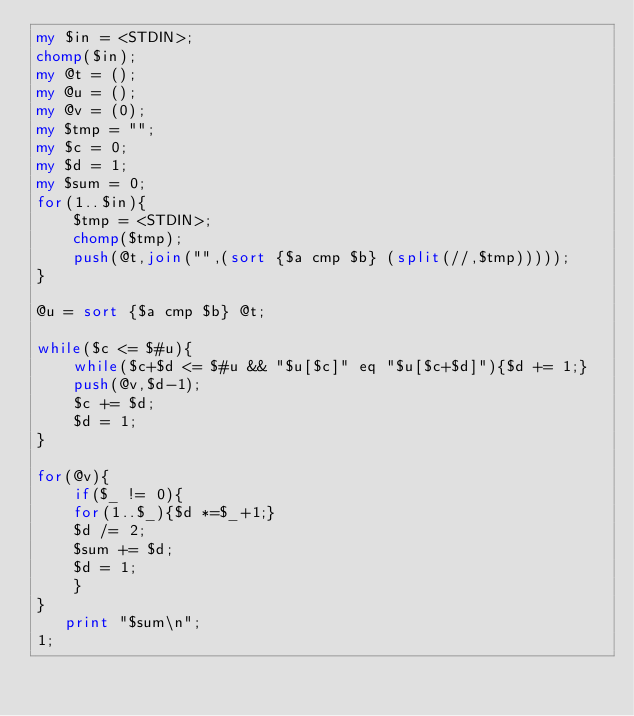Convert code to text. <code><loc_0><loc_0><loc_500><loc_500><_Perl_>my $in = <STDIN>;
chomp($in);
my @t = ();
my @u = ();
my @v = (0);
my $tmp = "";
my $c = 0;
my $d = 1;
my $sum = 0;
for(1..$in){
    $tmp = <STDIN>;
    chomp($tmp);
    push(@t,join("",(sort {$a cmp $b} (split(//,$tmp)))));
}

@u = sort {$a cmp $b} @t;

while($c <= $#u){
    while($c+$d <= $#u && "$u[$c]" eq "$u[$c+$d]"){$d += 1;}
    push(@v,$d-1);
    $c += $d;
    $d = 1;
}

for(@v){
    if($_ != 0){
	for(1..$_){$d *=$_+1;}
	$d /= 2;
	$sum += $d;
	$d = 1;
    }
}
   print "$sum\n";
1;
</code> 